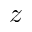Convert formula to latex. <formula><loc_0><loc_0><loc_500><loc_500>z</formula> 